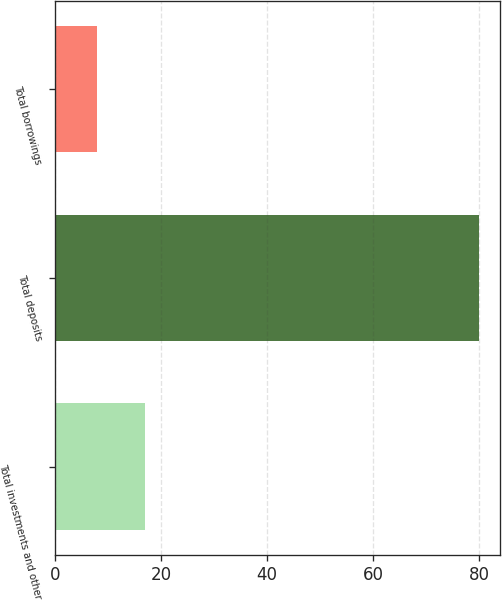<chart> <loc_0><loc_0><loc_500><loc_500><bar_chart><fcel>Total investments and other<fcel>Total deposits<fcel>Total borrowings<nl><fcel>17<fcel>80<fcel>8<nl></chart> 